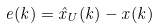<formula> <loc_0><loc_0><loc_500><loc_500>e ( k ) = { \hat { x } } _ { U } ( k ) - x ( k )</formula> 